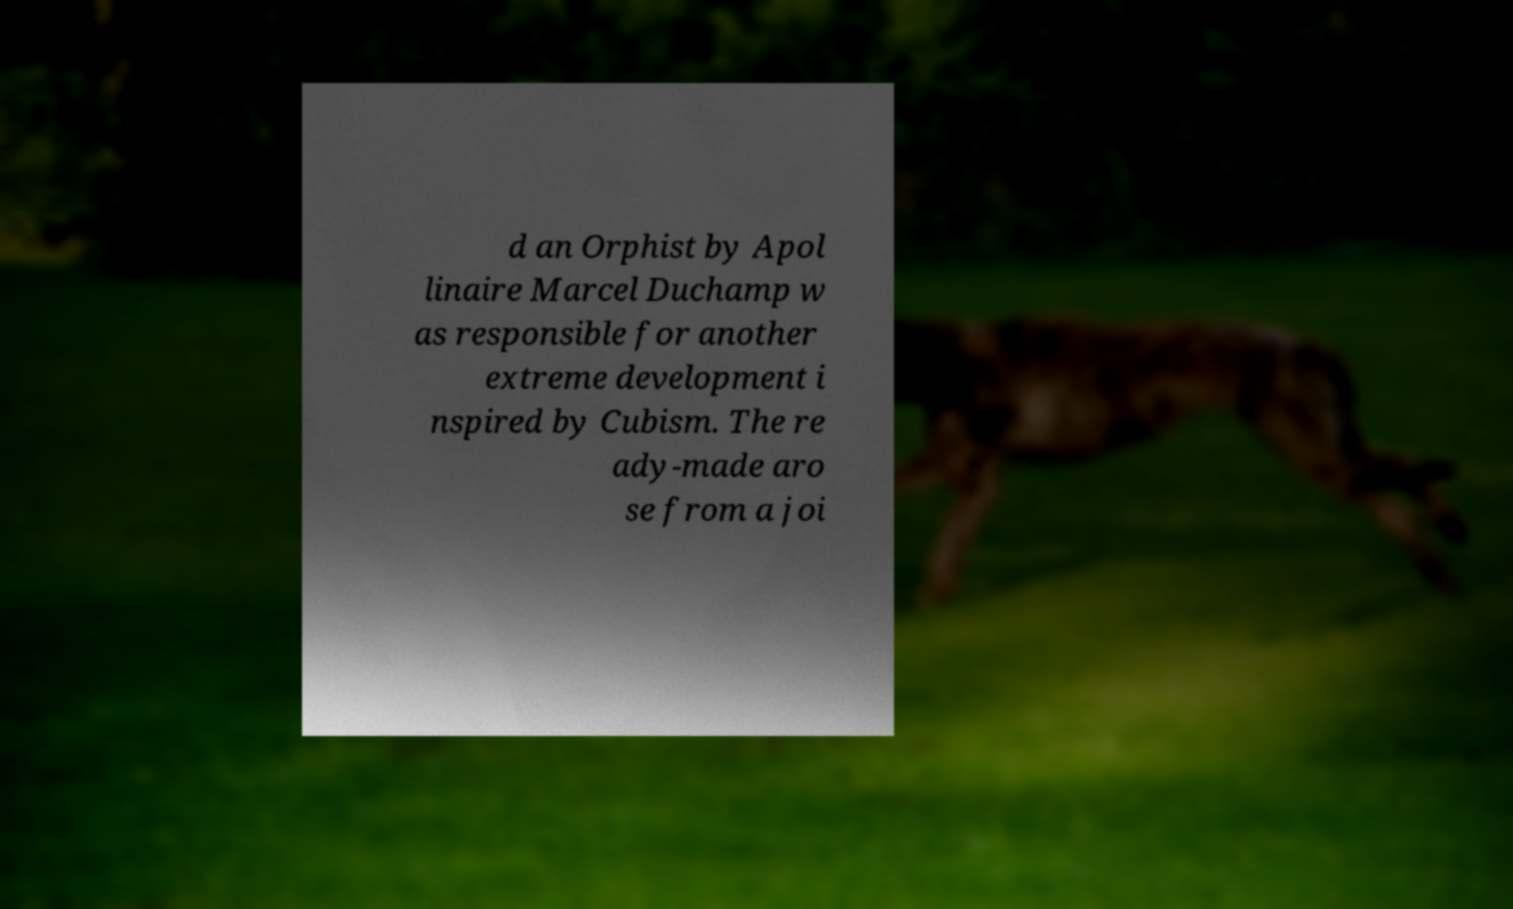Please read and relay the text visible in this image. What does it say? d an Orphist by Apol linaire Marcel Duchamp w as responsible for another extreme development i nspired by Cubism. The re ady-made aro se from a joi 